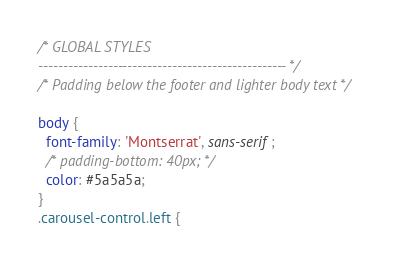Convert code to text. <code><loc_0><loc_0><loc_500><loc_500><_CSS_>
/* GLOBAL STYLES
-------------------------------------------------- */
/* Padding below the footer and lighter body text */

body {
  font-family: 'Montserrat', sans-serif;
  /* padding-bottom: 40px; */
  color: #5a5a5a;
}
.carousel-control.left {</code> 